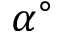<formula> <loc_0><loc_0><loc_500><loc_500>\alpha ^ { \circ }</formula> 